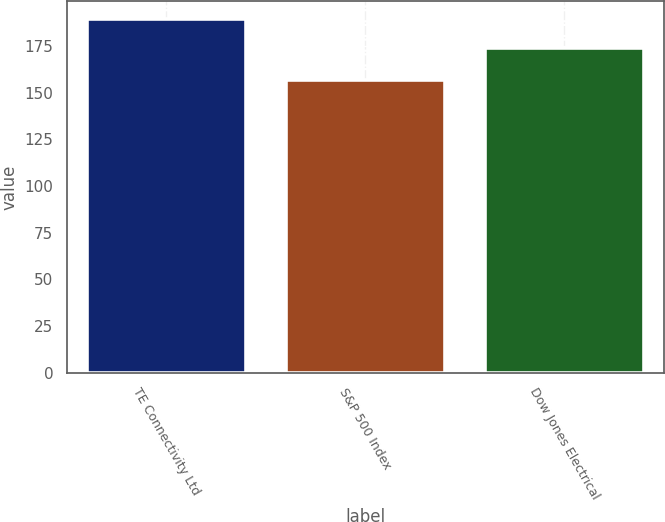Convert chart to OTSL. <chart><loc_0><loc_0><loc_500><loc_500><bar_chart><fcel>TE Connectivity Ltd<fcel>S&P 500 Index<fcel>Dow Jones Electrical<nl><fcel>189.53<fcel>157.13<fcel>174.12<nl></chart> 